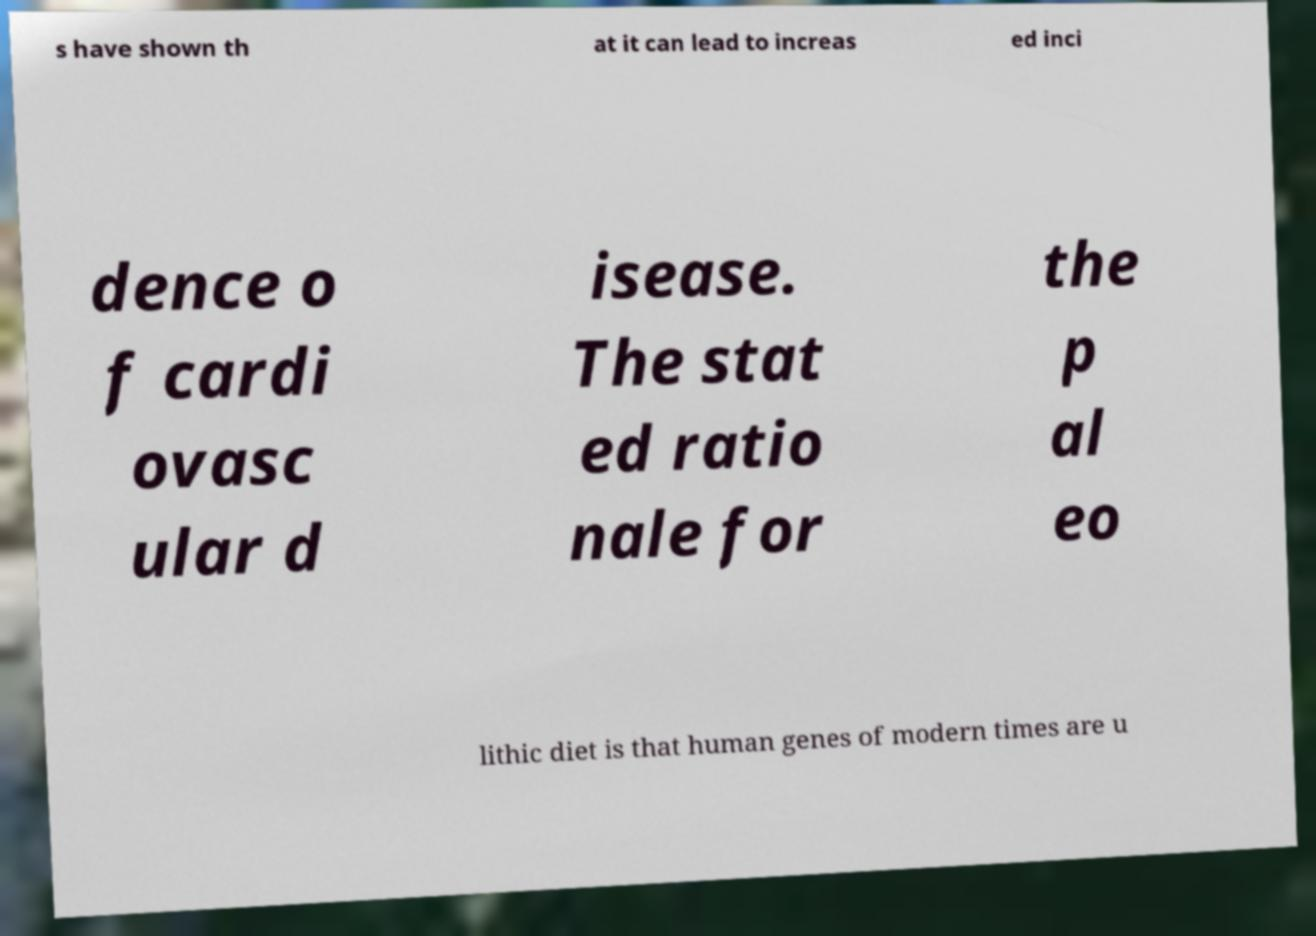Please read and relay the text visible in this image. What does it say? s have shown th at it can lead to increas ed inci dence o f cardi ovasc ular d isease. The stat ed ratio nale for the p al eo lithic diet is that human genes of modern times are u 